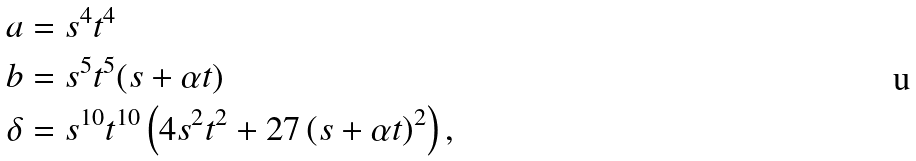Convert formula to latex. <formula><loc_0><loc_0><loc_500><loc_500>a & = s ^ { 4 } t ^ { 4 } \\ b & = s ^ { 5 } t ^ { 5 } ( s + \alpha t ) \\ \delta & = s ^ { 1 0 } t ^ { 1 0 } \left ( 4 s ^ { 2 } t ^ { 2 } + 2 7 \left ( s + \alpha t \right ) ^ { 2 } \right ) ,</formula> 